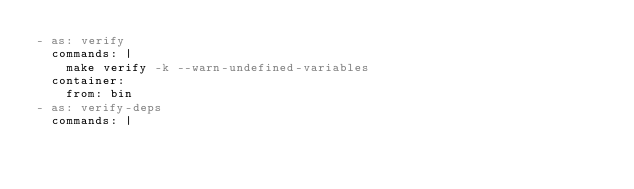<code> <loc_0><loc_0><loc_500><loc_500><_YAML_>- as: verify
  commands: |
    make verify -k --warn-undefined-variables
  container:
    from: bin
- as: verify-deps
  commands: |</code> 